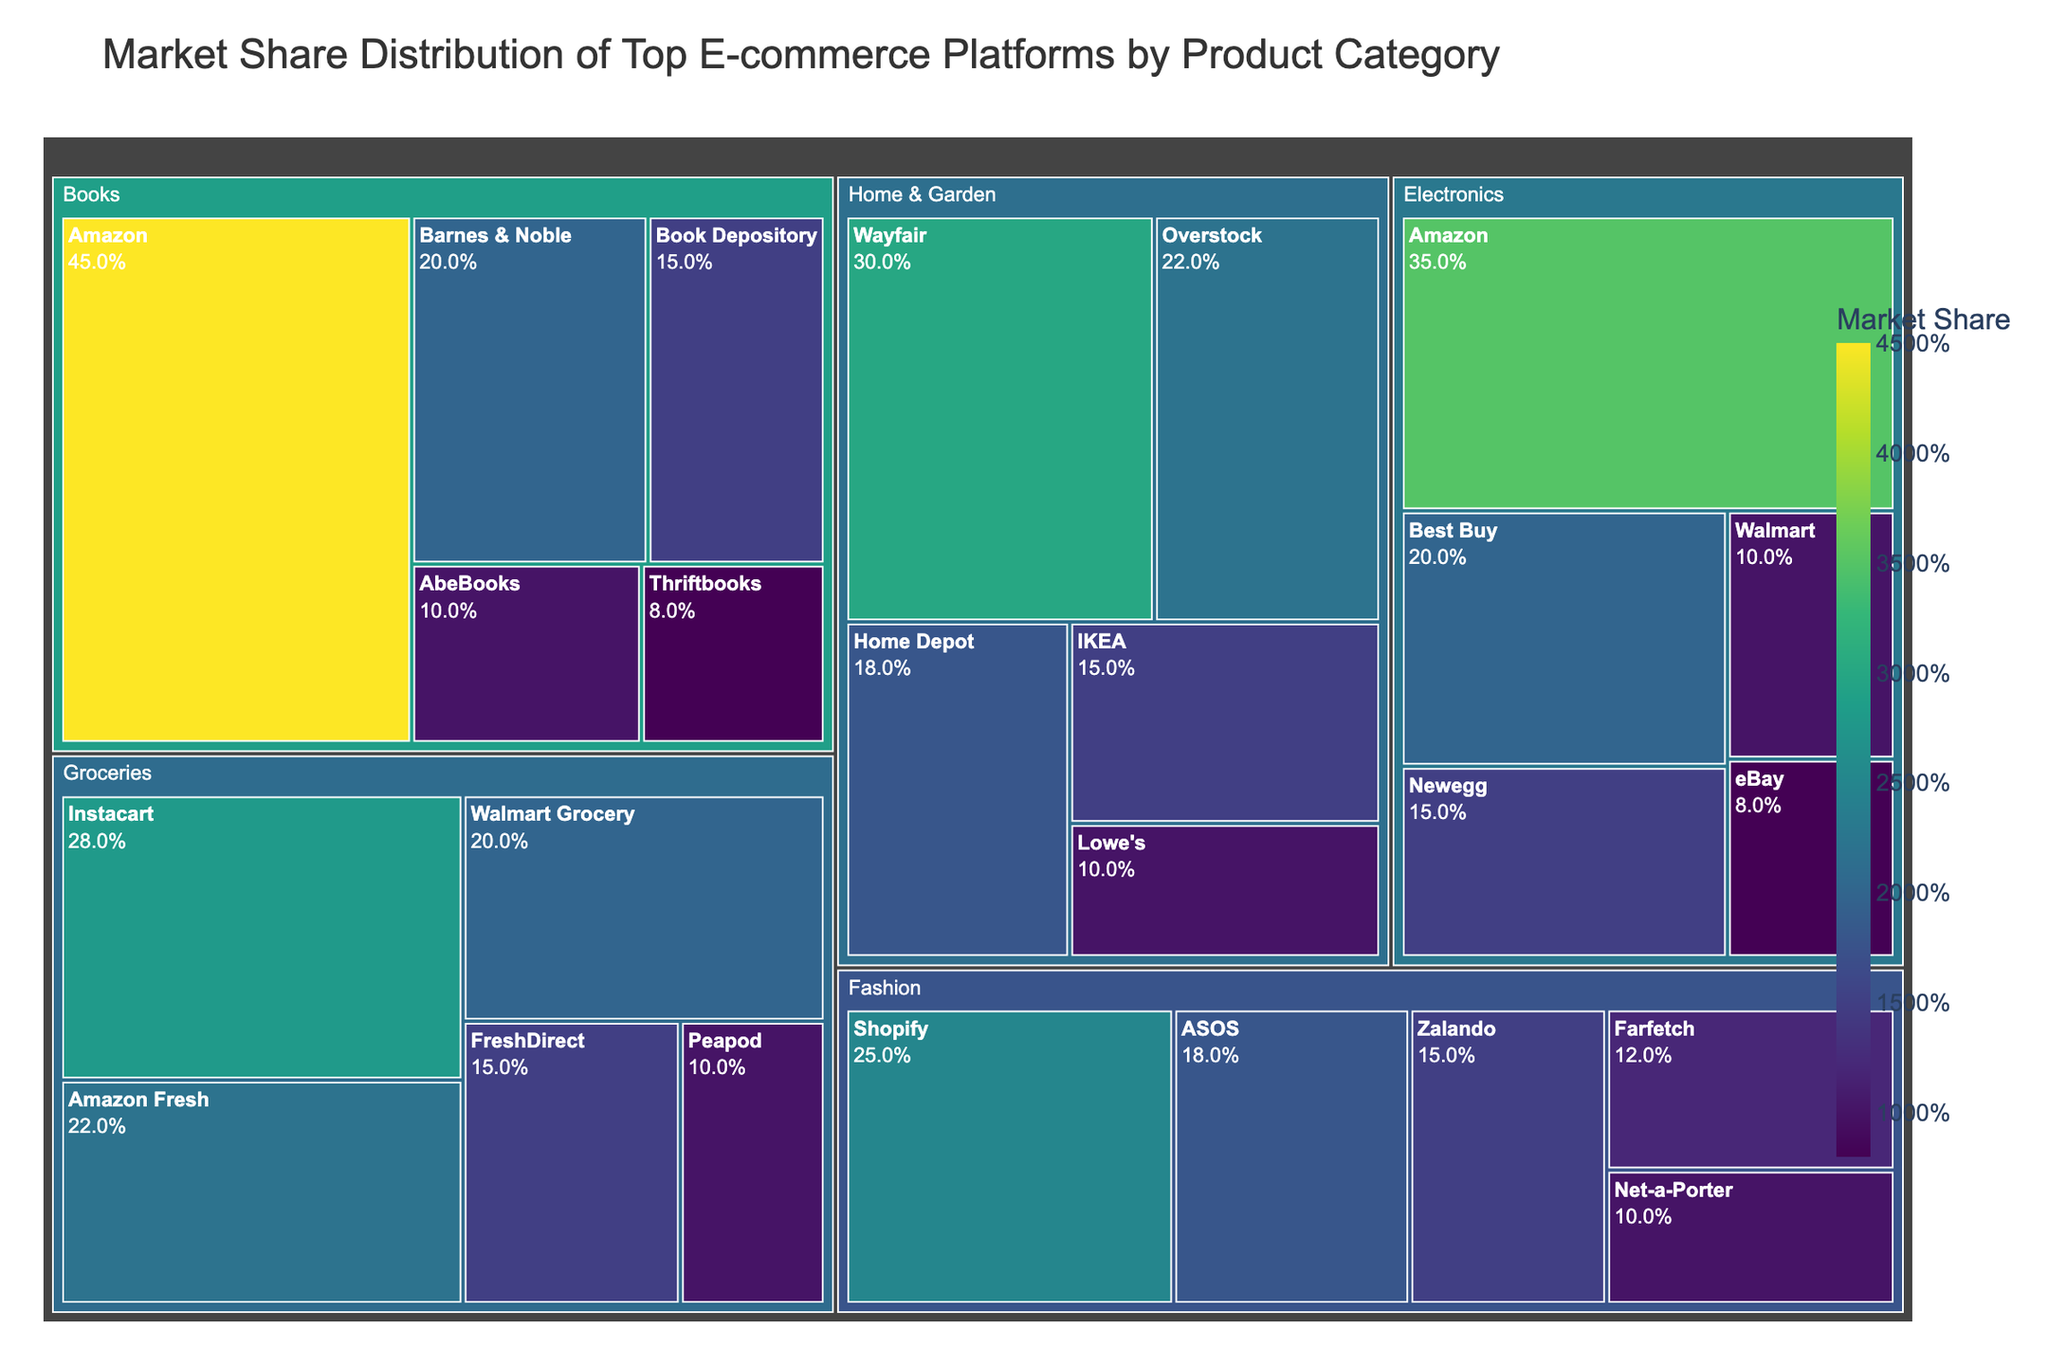what is the title of the figure? Look at the top of the figure to find the title text.
Answer: Market Share Distribution of Top E-commerce Platforms by Product Category How much market share does Amazon have in the Electronics category? Find the "Electronics" section of the treemap and locate the Amazon segment to see its market share value.
Answer: 35% Which platform has the lowest market share in the Fashion category? Find the "Fashion" section of the treemap and identify the segment with the smallest size, labeled with the lowest market share value.
Answer: Net-a-Porter What is the combined market share of Overstock and IKEA in the Home & Garden category? Locate the Home & Garden section and find the Overstock and IKEA segments. Sum their respective market share values: 22% (Overstock) + 15% (IKEA) = 37%
Answer: 37% Which category does Walmart participate in and what are their market shares in each? Locate each instance of Walmart in the treemap and read the associated categories and market share values.
Answer: Electronics: 10%, Groceries: 20% In the Books category, which platform has the second-highest market share? Look at the Books section and arrange platforms by market share, then identify the second-largest segment.
Answer: Barnes & Noble How does the market share of Wayfair in Home & Garden compare to Amazon Fresh in Groceries? Identify the market share values of Wayfair in Home & Garden and Amazon Fresh in Groceries, then compare the two values.
Answer: Wayfair: 30%, Amazon Fresh: 22% - Wayfair is higher What is the total market share of all platforms in the Groceries category? Sum the market share values of all platforms in the Groceries category: 28% (Instacart) + 22% (Amazon Fresh) + 20% (Walmart Grocery) + 15% (FreshDirect) + 10% (Peapod) = 95%
Answer: 95% Which category has the highest representation by Amazon, and what is the market share in that category? Identify each category where Amazon participates and compare the market share values.
Answer: Books, 45% 